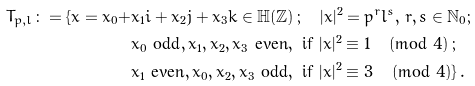<formula> <loc_0><loc_0><loc_500><loc_500>T _ { p , l } \colon = \{ x = x _ { 0 } + & x _ { 1 } i + x _ { 2 } j + x _ { 3 } k \in \mathbb { H } ( \mathbb { Z } ) \, ; \quad | x | ^ { 2 } = p ^ { r } l ^ { s } , \, r , s \in \mathbb { N } _ { 0 } ; \\ & x _ { 0 } \text { odd} , x _ { 1 } , x _ { 2 } , x _ { 3 } \text { even} , \text { if } | x | ^ { 2 } \equiv 1 \, \pmod { 4 } \, ; \\ & x _ { 1 } \text { even} , x _ { 0 } , x _ { 2 } , x _ { 3 } \text { odd} , \text { if } | x | ^ { 2 } \equiv 3 \, \pmod { 4 } \} \, .</formula> 